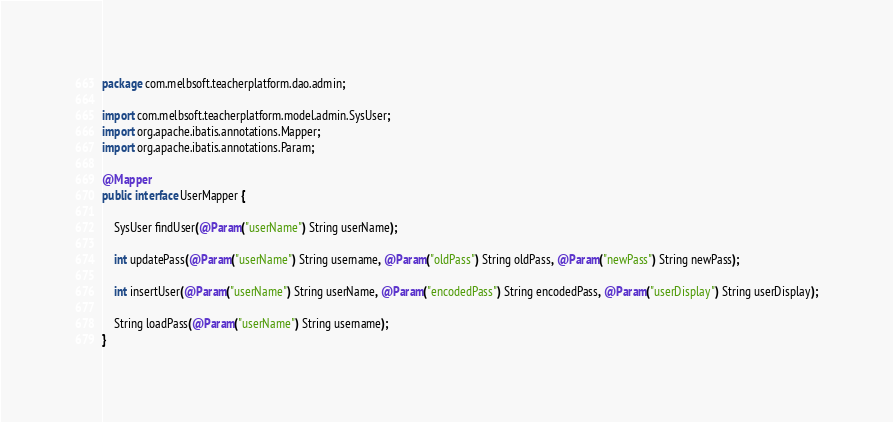<code> <loc_0><loc_0><loc_500><loc_500><_Java_>package com.melbsoft.teacherplatform.dao.admin;

import com.melbsoft.teacherplatform.model.admin.SysUser;
import org.apache.ibatis.annotations.Mapper;
import org.apache.ibatis.annotations.Param;

@Mapper
public interface UserMapper {

    SysUser findUser(@Param("userName") String userName);

    int updatePass(@Param("userName") String username, @Param("oldPass") String oldPass, @Param("newPass") String newPass);

    int insertUser(@Param("userName") String userName, @Param("encodedPass") String encodedPass, @Param("userDisplay") String userDisplay);

    String loadPass(@Param("userName") String username);
}
</code> 